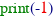Convert code to text. <code><loc_0><loc_0><loc_500><loc_500><_Python_>print(-1)</code> 